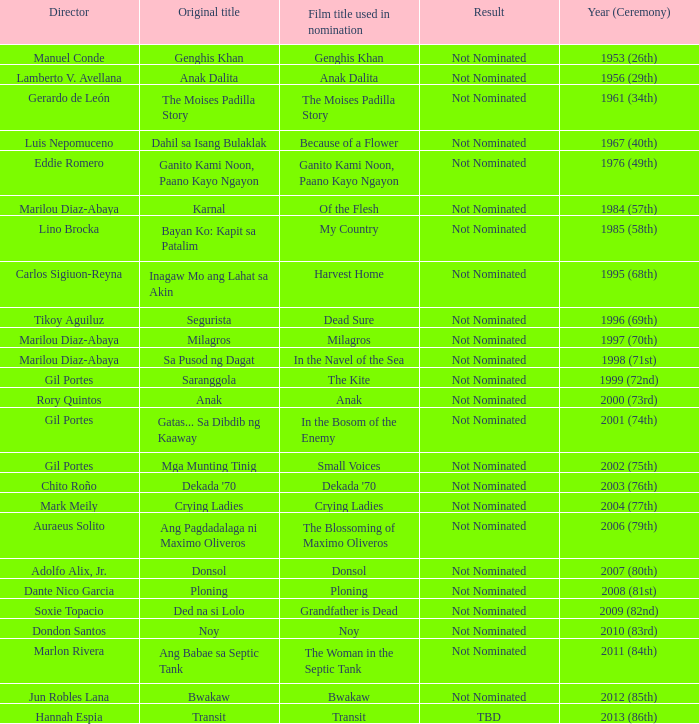Who was the director of Small Voices, a film title used in nomination? Gil Portes. 